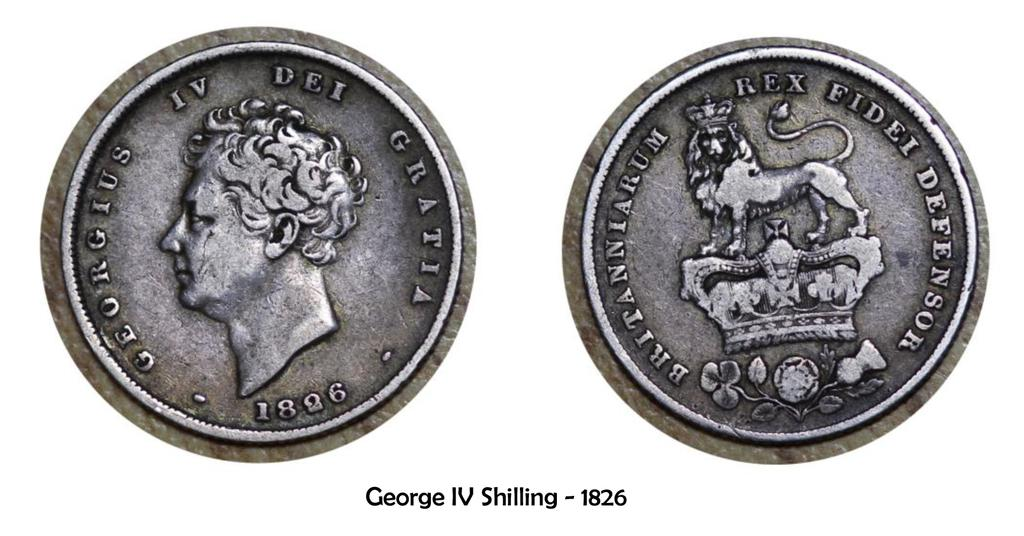<image>
Provide a brief description of the given image. silver coins next to one another with one that said iv dei gratia 